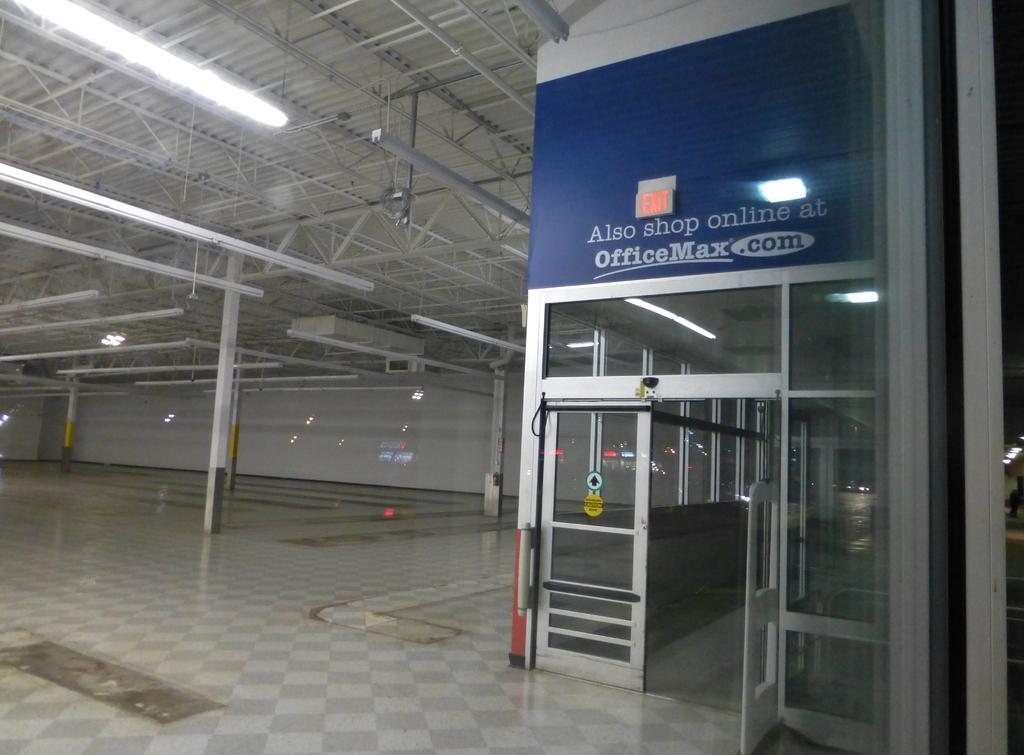Describe this image in one or two sentences. In this picture there is a door and on the top of the door there is a board with some text written on it. In the background there are pillars and at the top there are lights, there are windows in the center. 